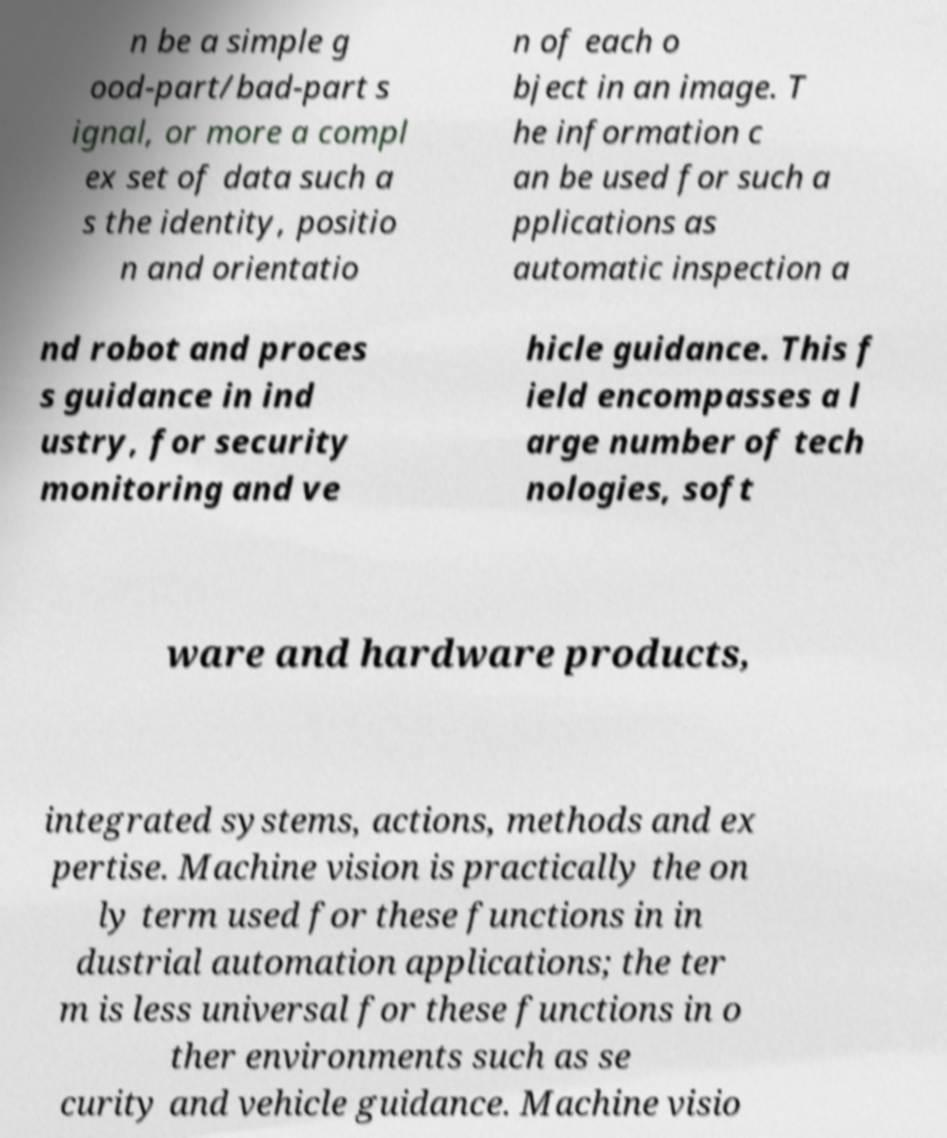For documentation purposes, I need the text within this image transcribed. Could you provide that? n be a simple g ood-part/bad-part s ignal, or more a compl ex set of data such a s the identity, positio n and orientatio n of each o bject in an image. T he information c an be used for such a pplications as automatic inspection a nd robot and proces s guidance in ind ustry, for security monitoring and ve hicle guidance. This f ield encompasses a l arge number of tech nologies, soft ware and hardware products, integrated systems, actions, methods and ex pertise. Machine vision is practically the on ly term used for these functions in in dustrial automation applications; the ter m is less universal for these functions in o ther environments such as se curity and vehicle guidance. Machine visio 